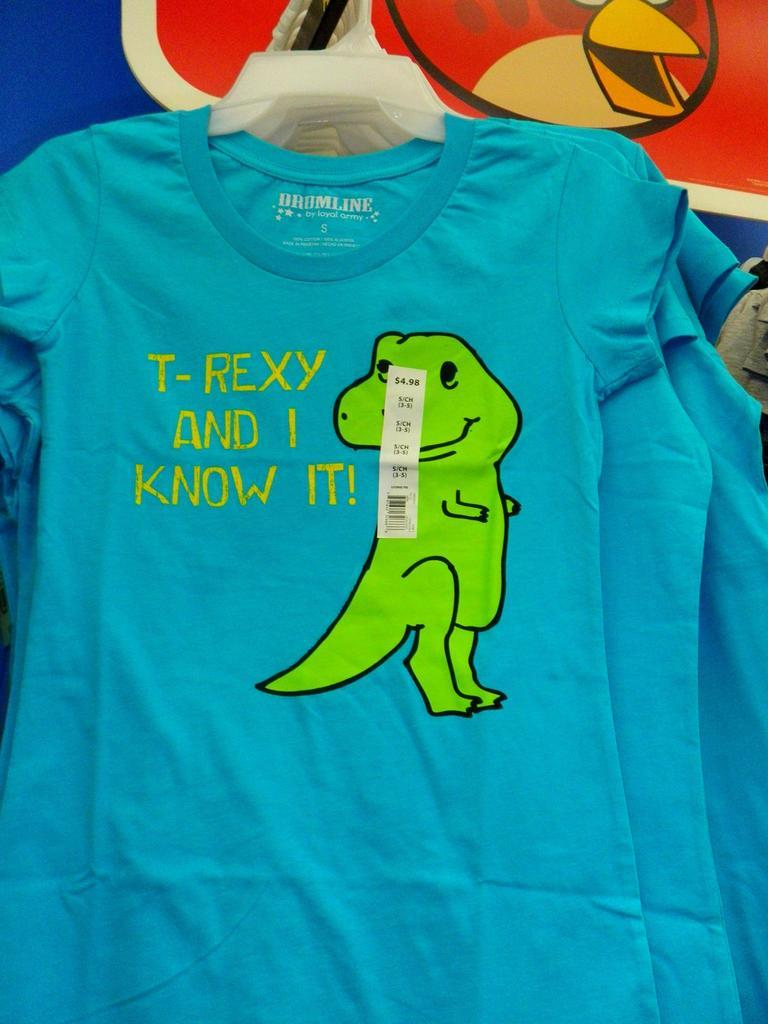What color are the t-shirts in the image? The t-shirts in the image are blue. How are the t-shirts positioned in the image? The t-shirts are hanging on a hanger. What design is featured on the t-shirts? There is a green cartoon on the t-shirts. What flavor of goat cheese is being served with the t-shirts in the image? There is no goat cheese present in the image, as it features blue t-shirts with a green cartoon design. How comfortable are the t-shirts in the image? The comfort level of the t-shirts cannot be determined from the image alone, as it only shows their color, design, and position on a hanger. 